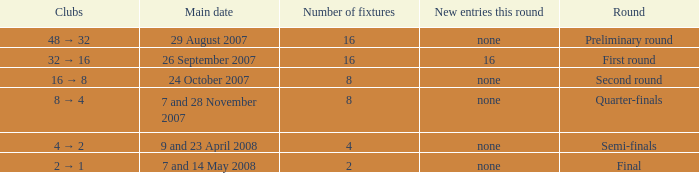What is the New entries this round when the round is the semi-finals? None. 